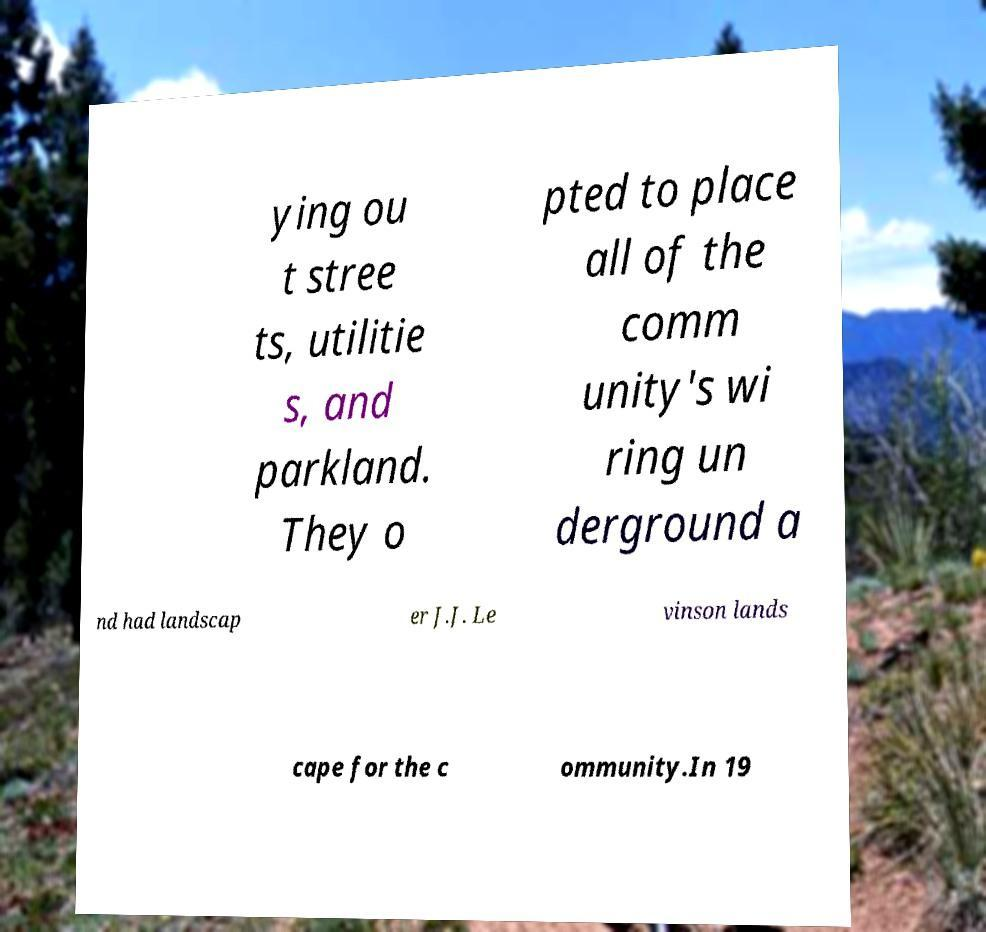I need the written content from this picture converted into text. Can you do that? ying ou t stree ts, utilitie s, and parkland. They o pted to place all of the comm unity's wi ring un derground a nd had landscap er J.J. Le vinson lands cape for the c ommunity.In 19 